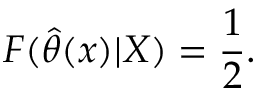Convert formula to latex. <formula><loc_0><loc_0><loc_500><loc_500>F ( { \widehat { \theta } } ( x ) | X ) = { \frac { 1 } { 2 } } .</formula> 